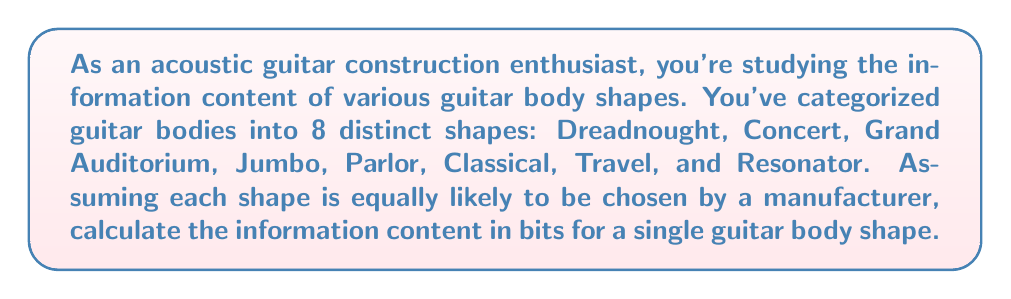Could you help me with this problem? To solve this problem, we'll use the concept of information content from information theory. The information content of an event is measured in bits and is calculated using the formula:

$$I(x) = -\log_2(p(x))$$

Where $I(x)$ is the information content of event $x$, and $p(x)$ is the probability of event $x$ occurring.

Given:
- There are 8 distinct guitar body shapes.
- Each shape is equally likely to be chosen.

Step 1: Calculate the probability of each shape being chosen.
Since all shapes are equally likely, the probability of each shape is:

$$p(x) = \frac{1}{8} = 0.125$$

Step 2: Calculate the information content using the formula.

$$\begin{align}
I(x) &= -\log_2(p(x)) \\
&= -\log_2(0.125) \\
&= -\log_2(\frac{1}{8}) \\
&= -(-3) \\
&= 3 \text{ bits}
\end{align}$$

This result means that each guitar body shape carries 3 bits of information.

To understand this intuitively, consider that $2^3 = 8$, which is the number of distinct shapes. This means that 3 bits are sufficient to uniquely identify each of the 8 shapes.
Answer: The information content of a single guitar body shape is 3 bits. 